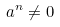Convert formula to latex. <formula><loc_0><loc_0><loc_500><loc_500>a ^ { n } \neq 0</formula> 